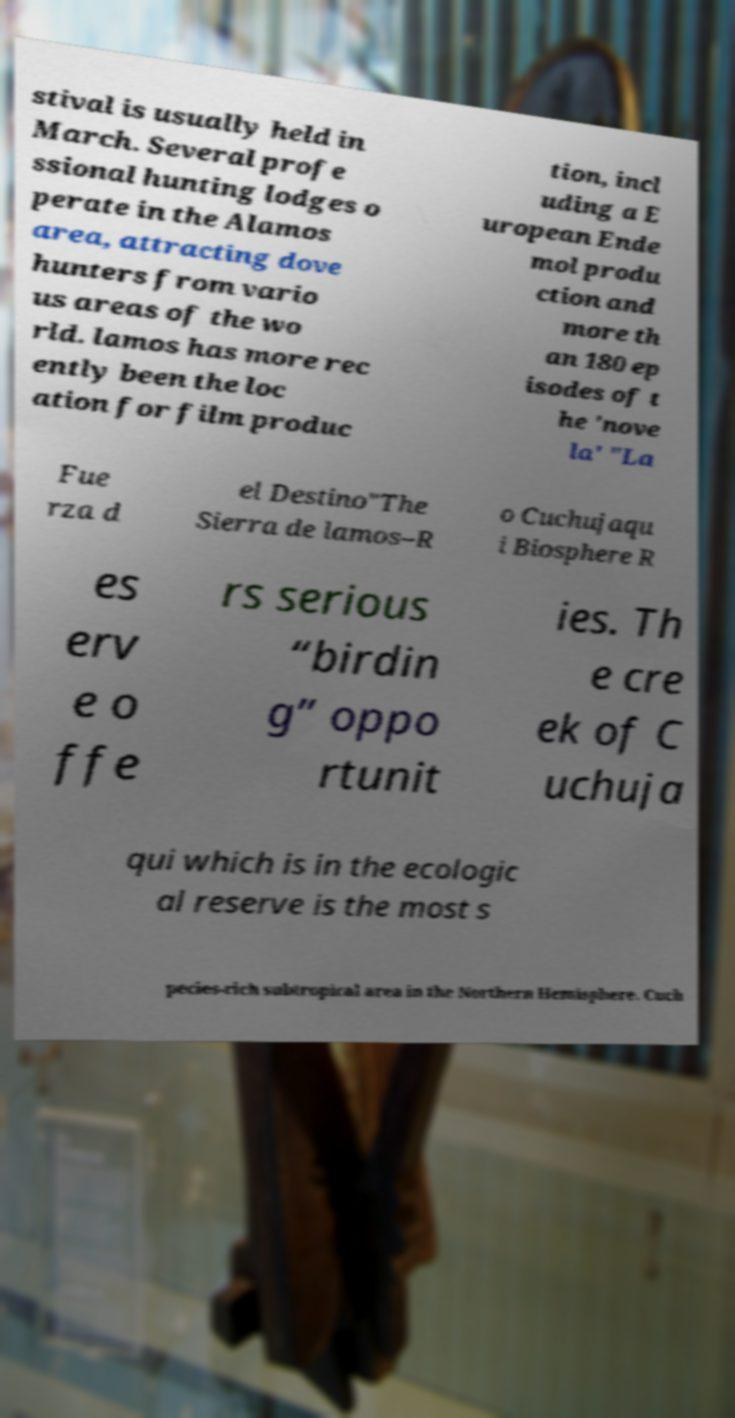Please identify and transcribe the text found in this image. stival is usually held in March. Several profe ssional hunting lodges o perate in the Alamos area, attracting dove hunters from vario us areas of the wo rld. lamos has more rec ently been the loc ation for film produc tion, incl uding a E uropean Ende mol produ ction and more th an 180 ep isodes of t he 'nove la' "La Fue rza d el Destino"The Sierra de lamos–R o Cuchujaqu i Biosphere R es erv e o ffe rs serious “birdin g” oppo rtunit ies. Th e cre ek of C uchuja qui which is in the ecologic al reserve is the most s pecies-rich subtropical area in the Northern Hemisphere. Cuch 